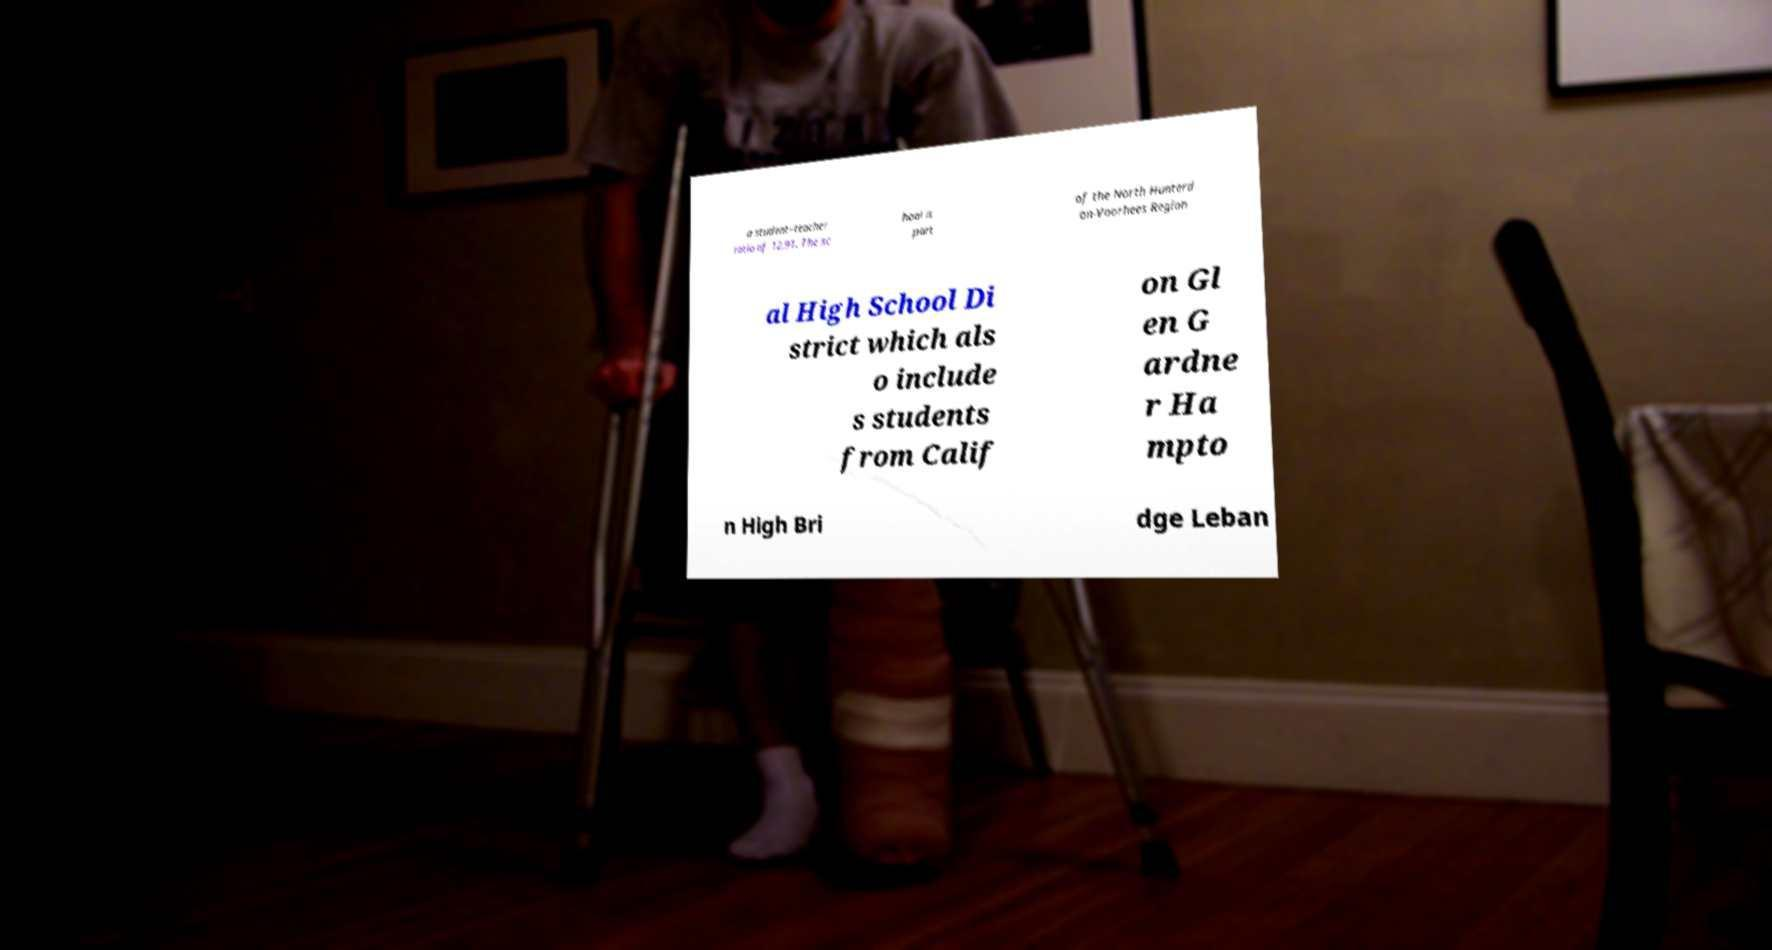Can you read and provide the text displayed in the image?This photo seems to have some interesting text. Can you extract and type it out for me? a student–teacher ratio of 12.91. The sc hool is part of the North Hunterd on-Voorhees Region al High School Di strict which als o include s students from Calif on Gl en G ardne r Ha mpto n High Bri dge Leban 